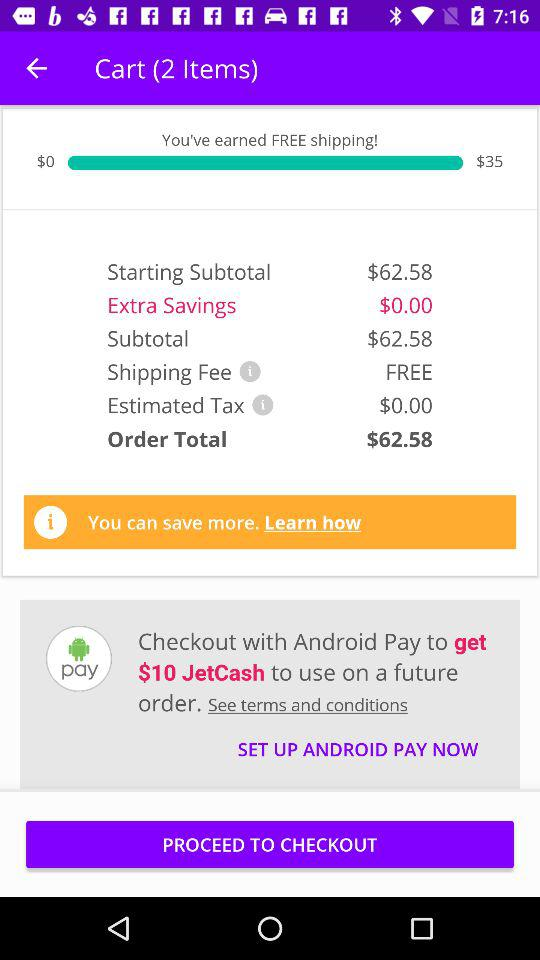What is the starting subtotal? The starting subtotal is $62.58. 